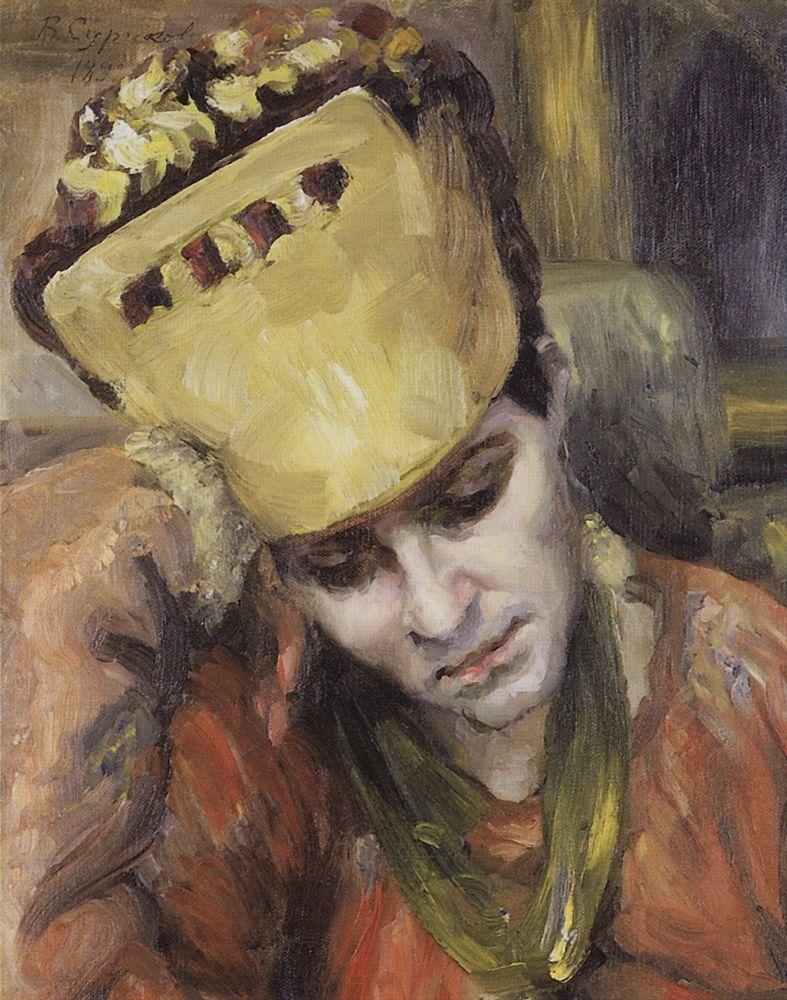Based on the painting, write a long and realistic scenario. Marielle, the subject of the painting, is a young woman living in early 20th-century Paris. She works as a seamstress in a small atelier, crafting elaborate garments for the city's elite. Despite the bustling activity around her, Marielle often finds herself lost in thought, reflecting on her aspirations and the limitations imposed by her socio-economic status. The vibrant yellow hat she wears is a cherished possession, a gift from her beloved grandmother who always encouraged her to dream big. This moment captured on canvas represents an afternoon during her lunch break, where she seeks a quiet corner of the atelier to immerse herself in daydreams of becoming an acclaimed fashion designer. The artist, a friend who visits the atelier, is moved by her contemplative demeanor and the contrast between her vibrant hat and the shadows of the workshop. He decides to immortalize this poignant mix of hope and reality in his work. 